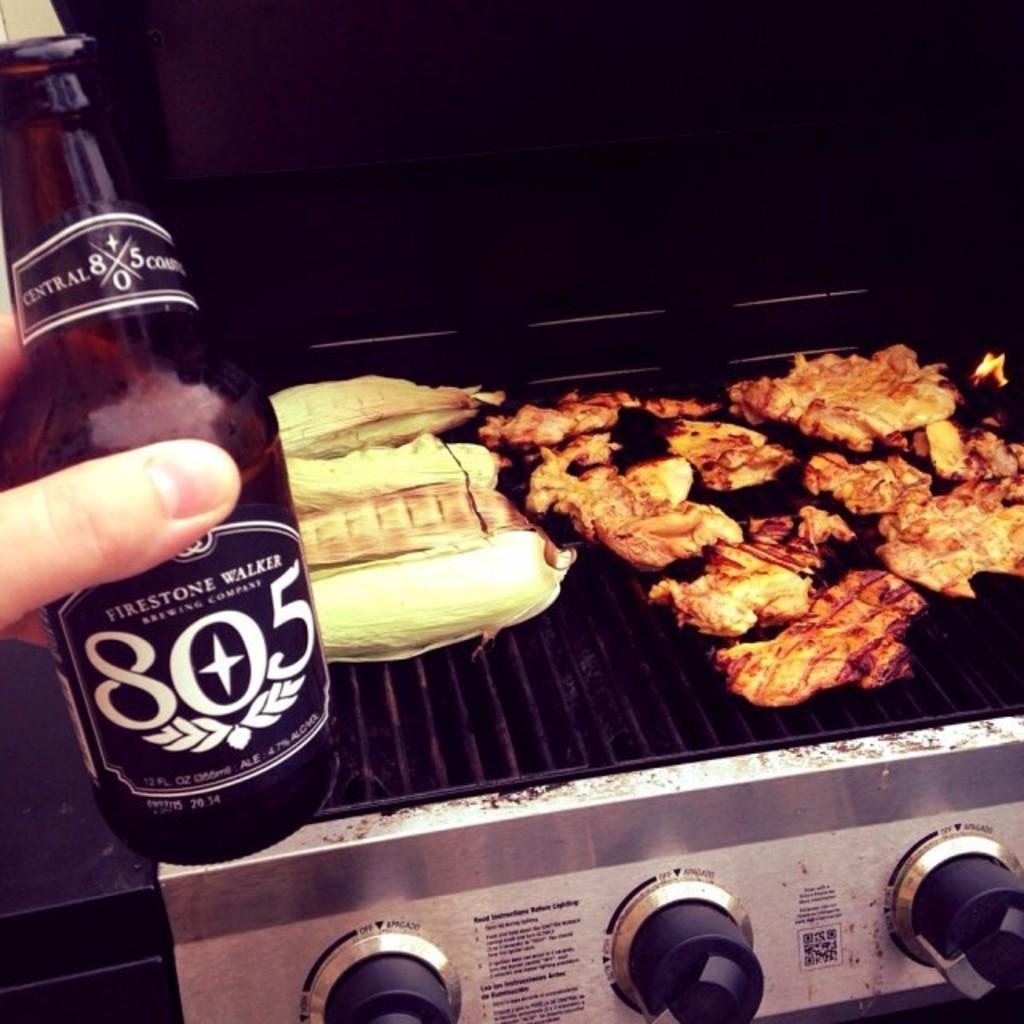<image>
Relay a brief, clear account of the picture shown. A bottle of Firestone Walker beer being held infront of a grill. 